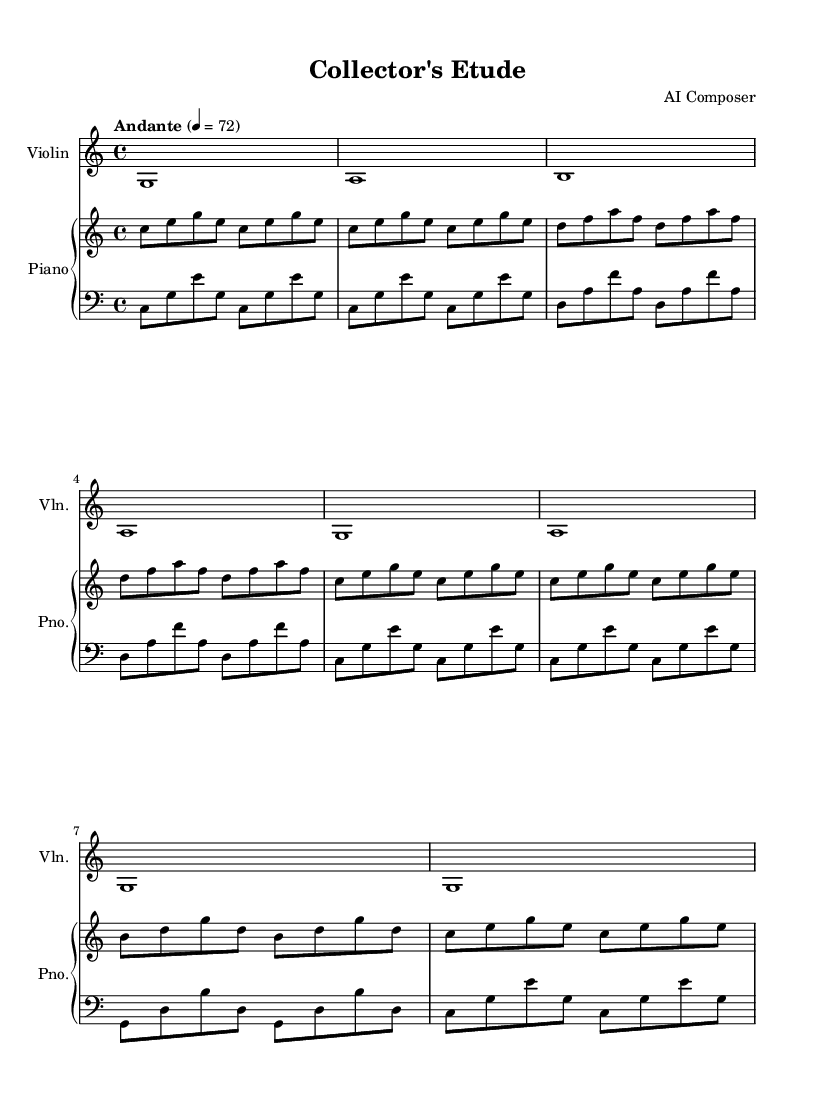What is the key signature of this music? The key signature is C major, which has no sharps or flats.
Answer: C major What is the time signature of this music? The time signature is indicated at the beginning of the score, showing that there are four beats per measure.
Answer: 4/4 What is the tempo marking for this piece? The tempo marking is found in the header section of the score, indicating the piece should be played at a speed of 72 beats per minute with the marking "Andante."
Answer: Andante How many measures are there in the violin part? Counting the individual measures in the violin part, there are a total of 8 measures throughout the piece.
Answer: 8 Which instrument plays the lowest notes? By examining the piano staff, the left hand (bass clef) plays lower pitches than the rest of the instruments.
Answer: Piano left hand What note does the piano right hand start on? The first note in the piano right hand section is a C, which can be located in the relative octave shown in the score.
Answer: C What is the general structure of this piece? The piece follows a simple A-B-A structure, where the A section is repeated with slight variations.
Answer: A-B-A 